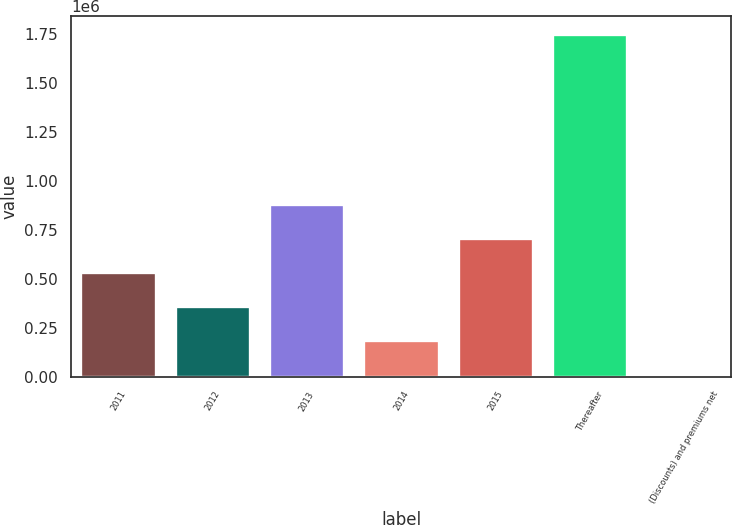<chart> <loc_0><loc_0><loc_500><loc_500><bar_chart><fcel>2011<fcel>2012<fcel>2013<fcel>2014<fcel>2015<fcel>Thereafter<fcel>(Discounts) and premiums net<nl><fcel>532620<fcel>358709<fcel>880443<fcel>184797<fcel>706532<fcel>1.75e+06<fcel>10886<nl></chart> 